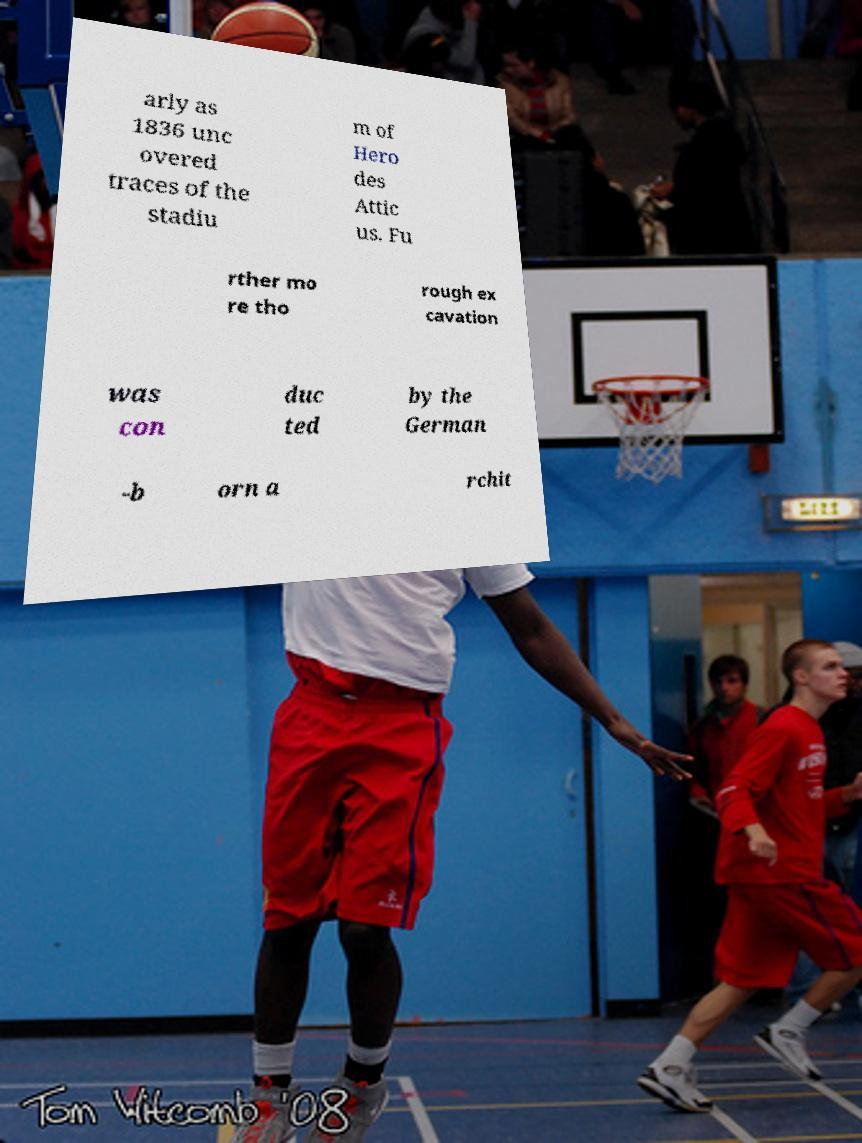There's text embedded in this image that I need extracted. Can you transcribe it verbatim? arly as 1836 unc overed traces of the stadiu m of Hero des Attic us. Fu rther mo re tho rough ex cavation was con duc ted by the German -b orn a rchit 